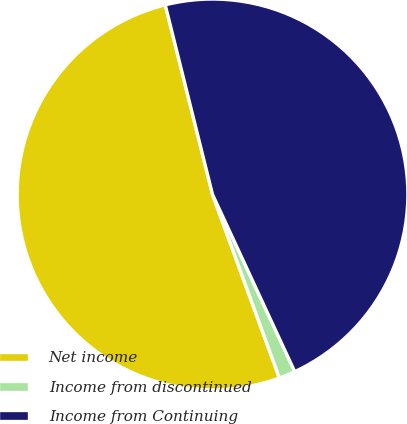Convert chart. <chart><loc_0><loc_0><loc_500><loc_500><pie_chart><fcel>Net income<fcel>Income from discontinued<fcel>Income from Continuing<nl><fcel>51.67%<fcel>1.35%<fcel>46.97%<nl></chart> 